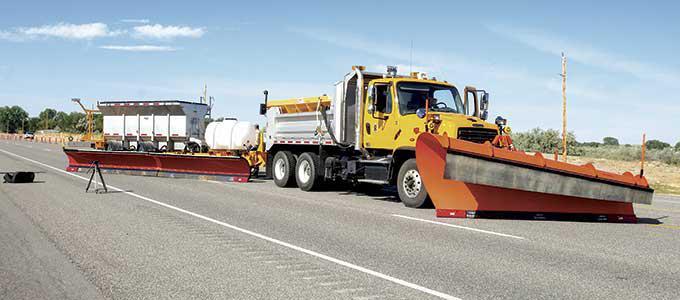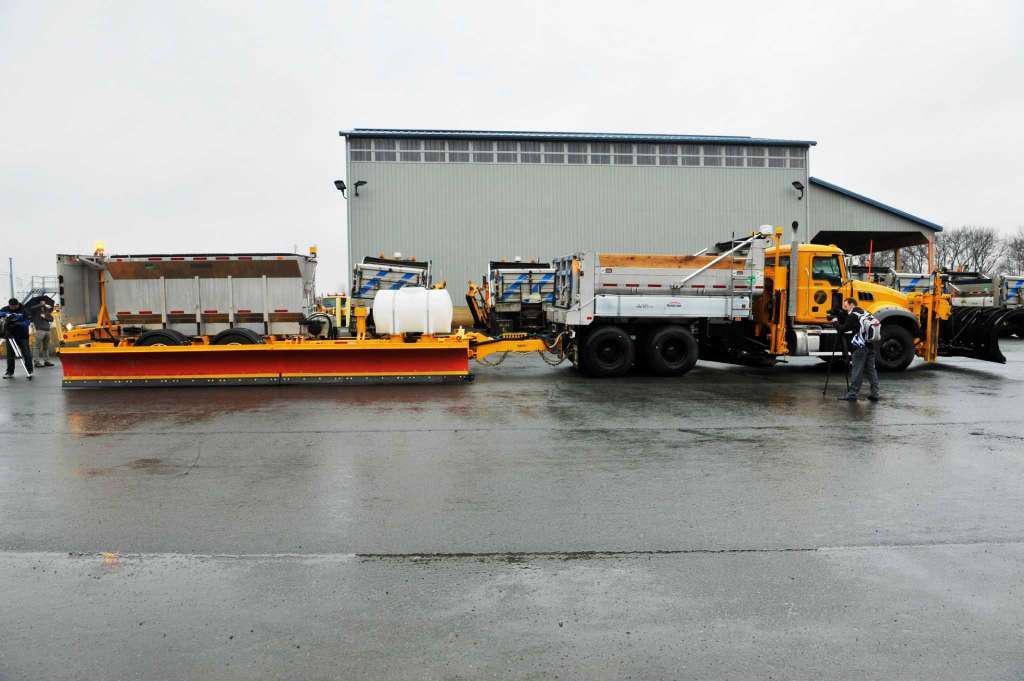The first image is the image on the left, the second image is the image on the right. For the images displayed, is the sentence "The truck on the right has a plow, the truck on the left does not." factually correct? Answer yes or no. No. 